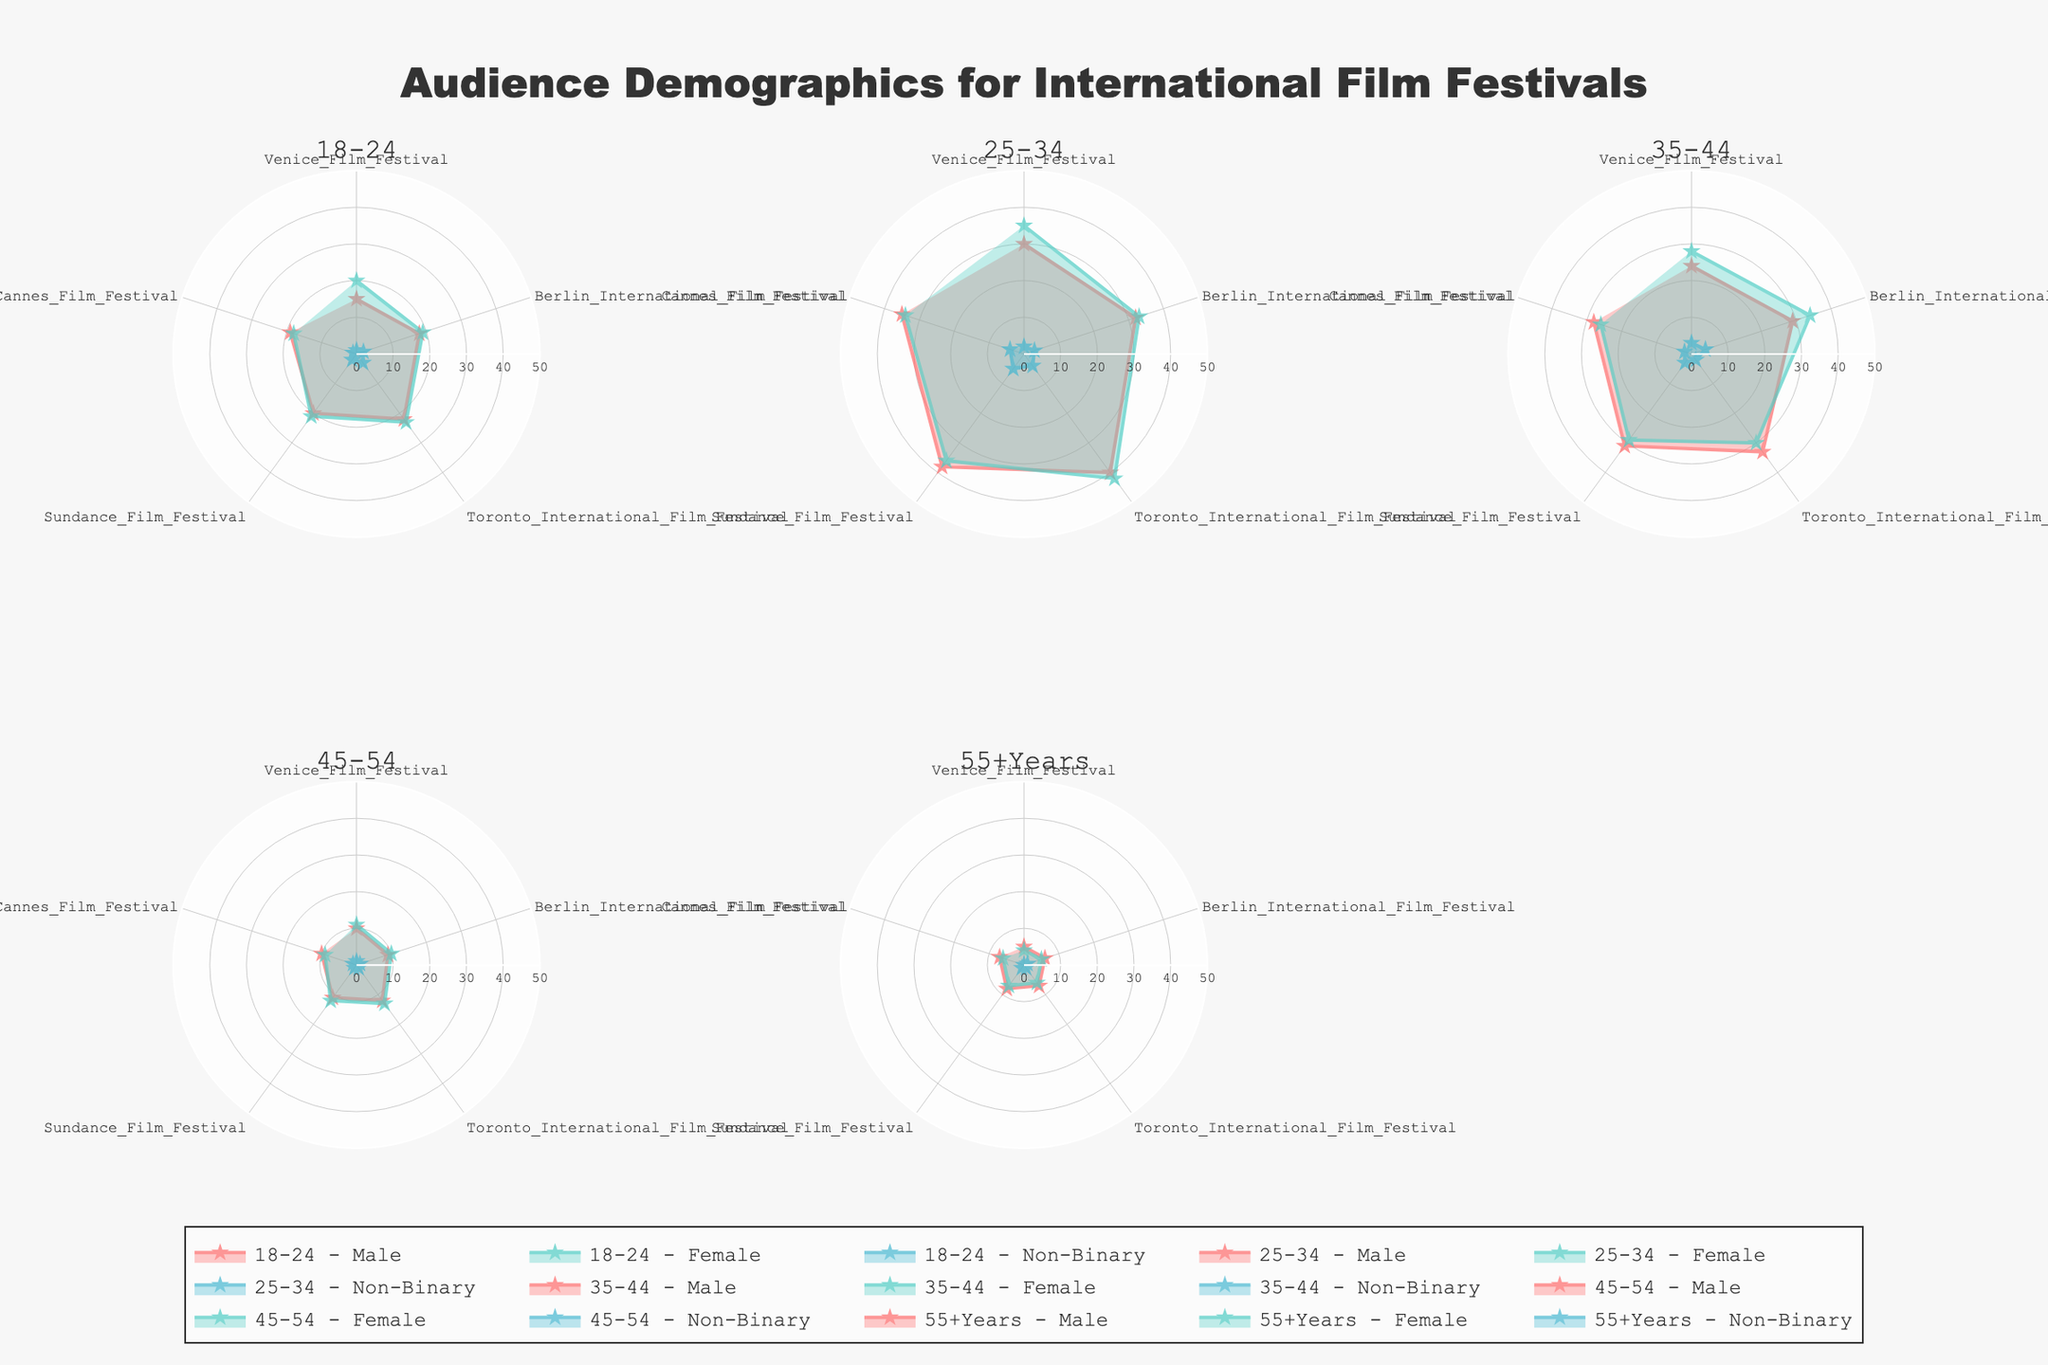What's the title of the figure? The title of the figure is displayed prominently at the top of the plot area.
Answer: Audience Demographics for International Film Festivals Which color represents male audience data in the radar charts? Male audience data is represented with a specific color in the radar charts. The color legend shows it's the first listed color typically displayed as a reddish hue.
Answer: Red What is the highest value represented in the 18-24 age group for males, and which festival does it correspond to? Looking at the subplot for the 18-24 age group for males, identify the highest data point on the radar chart and note which festival it corresponds to.
Answer: 22, Toronto International Film Festival Which gender has the highest representation in the Toronto International Film Festival for 25-34 age group? Go to the subplot for the 25-34 age group and compare the data points from different genders for Toronto International Film Festival.
Answer: Female What is the sum of the representation values for the Sundance Film Festival in the 35-44 age group? Locate the 35-44 age group subplot and add the values of Sundance Film Festival for male, female, and non-binary data points (31 + 29 + 3).
Answer: 63 How does the female audience's representation in the Cannes Film Festival compare across different age groups? Check the values of the Cannes Film Festival for the female audience in all subplots and compare them to identify differences.
Answer: 18 (18-24), 34 (25-34), 26 (35-44), 9 (45-54), 6 (55+Years) Which age group has the lowest representation of non-binary audience at the Venice Film Festival? Compare the Venice Film Festival data points for non-binary audiences across all subplots to determine the lowest value.
Answer: 55+Years What trend do you observe about the representation of students (18-24) across all the festivals? Look at the student age group (18-24) subplots and observe how their representation values vary across the different festivals.
Answer: Higher representation in Toronto and Sundance, similar lower representation in Venice and Cannes How does the representation of retired individuals (45-54 and 55+Years) compare between Berlin International Film Festival and Cannes Film Festival? Review the subplots for 45-54 and 55+Years and compare the data points for Berlin International Film Festival and Cannes Film Festival.
Answer: Higher in Berlin for 45-54; similar for 55+Years 